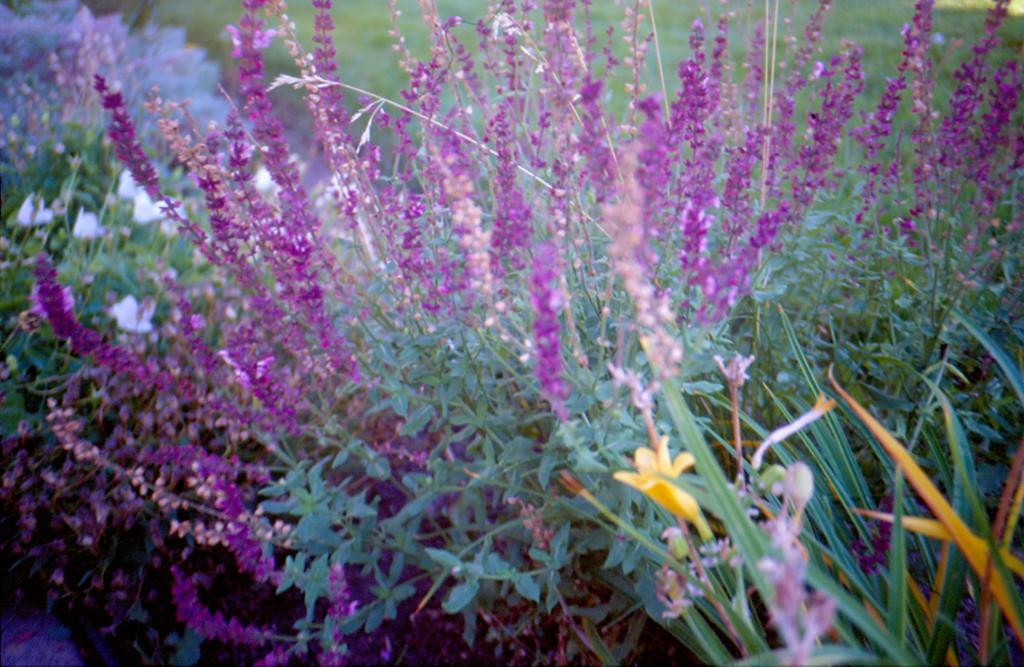What types of vegetation are in the front of the image? There are plants and flowers in the front of the image. Can you describe the plants and flowers in the image? The plants and flowers are not described in detail, but they are present in the front of the image. What type of vegetation is in the background of the image? There is grass in the background of the image. Where is the grass located in the image? The grass is on the ground in the background of the image. Can you see any ants crawling on the flowers in the image? There is no mention of ants in the image, so it cannot be determined if any are present. What discovery was made while observing the plants and flowers in the image? There is no mention of a discovery in the image, so it cannot be determined if any were made. 